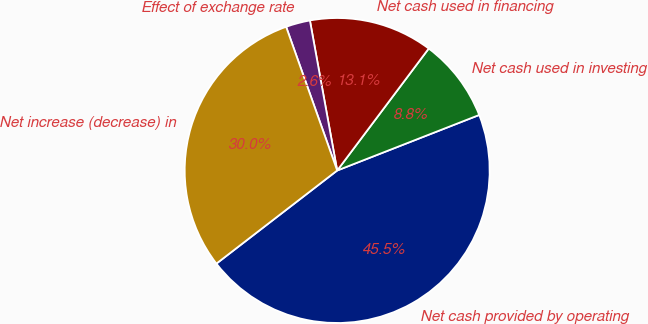<chart> <loc_0><loc_0><loc_500><loc_500><pie_chart><fcel>Net cash provided by operating<fcel>Net cash used in investing<fcel>Net cash used in financing<fcel>Effect of exchange rate<fcel>Net increase (decrease) in<nl><fcel>45.48%<fcel>8.82%<fcel>13.11%<fcel>2.57%<fcel>30.02%<nl></chart> 